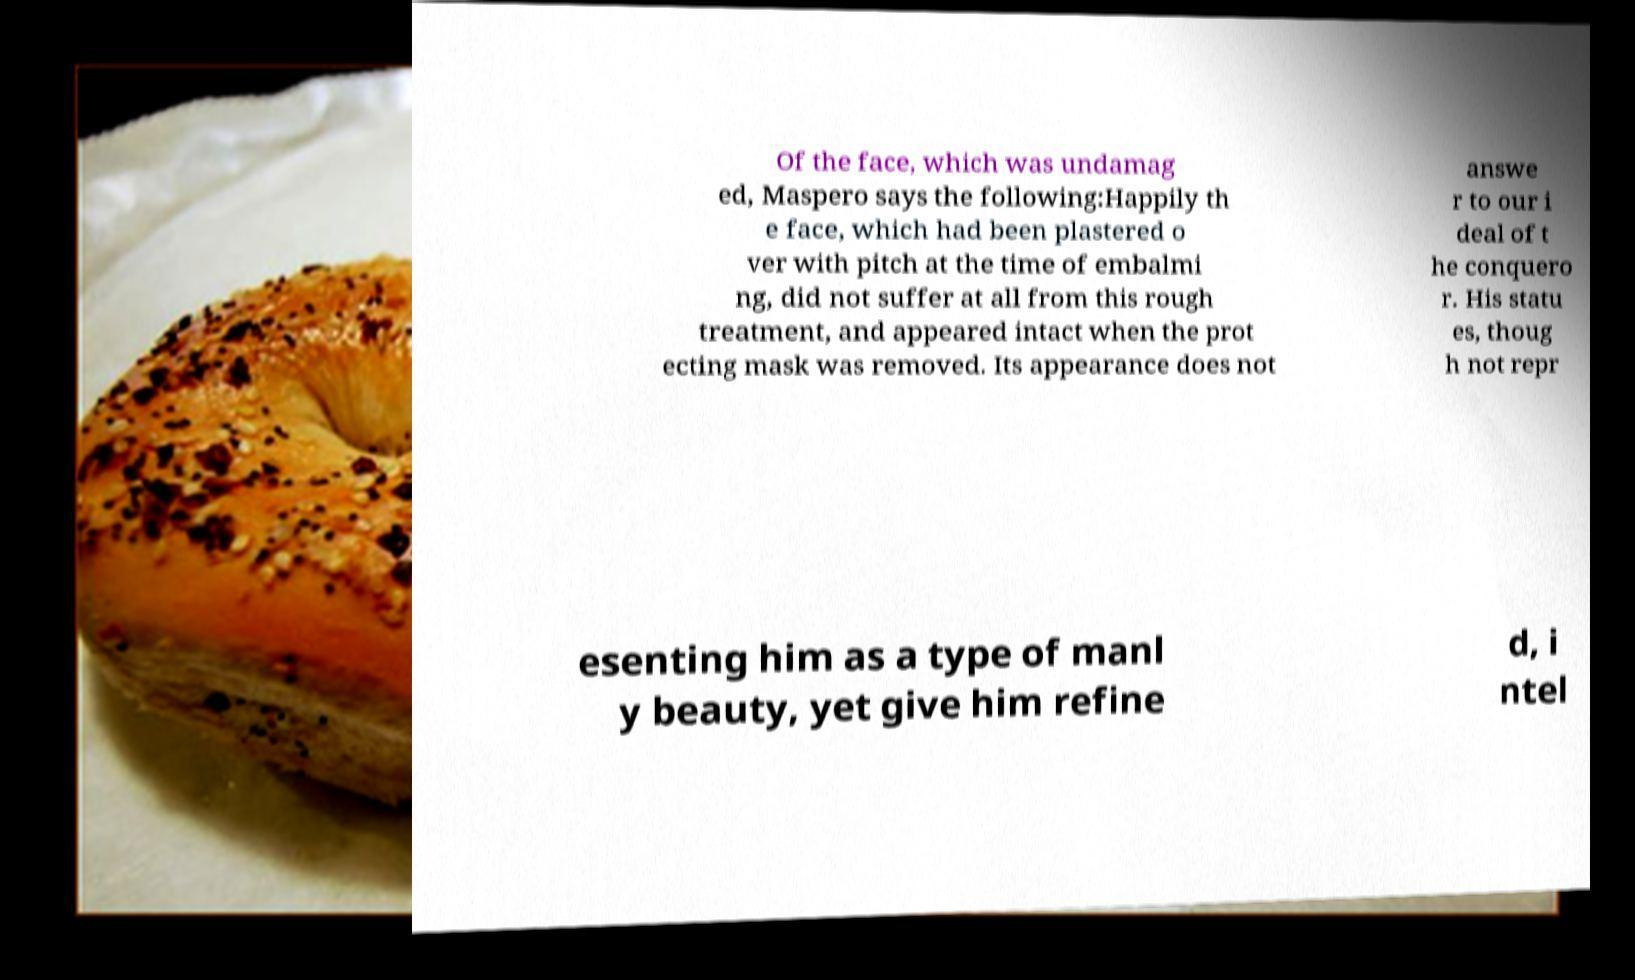Could you extract and type out the text from this image? Of the face, which was undamag ed, Maspero says the following:Happily th e face, which had been plastered o ver with pitch at the time of embalmi ng, did not suffer at all from this rough treatment, and appeared intact when the prot ecting mask was removed. Its appearance does not answe r to our i deal of t he conquero r. His statu es, thoug h not repr esenting him as a type of manl y beauty, yet give him refine d, i ntel 